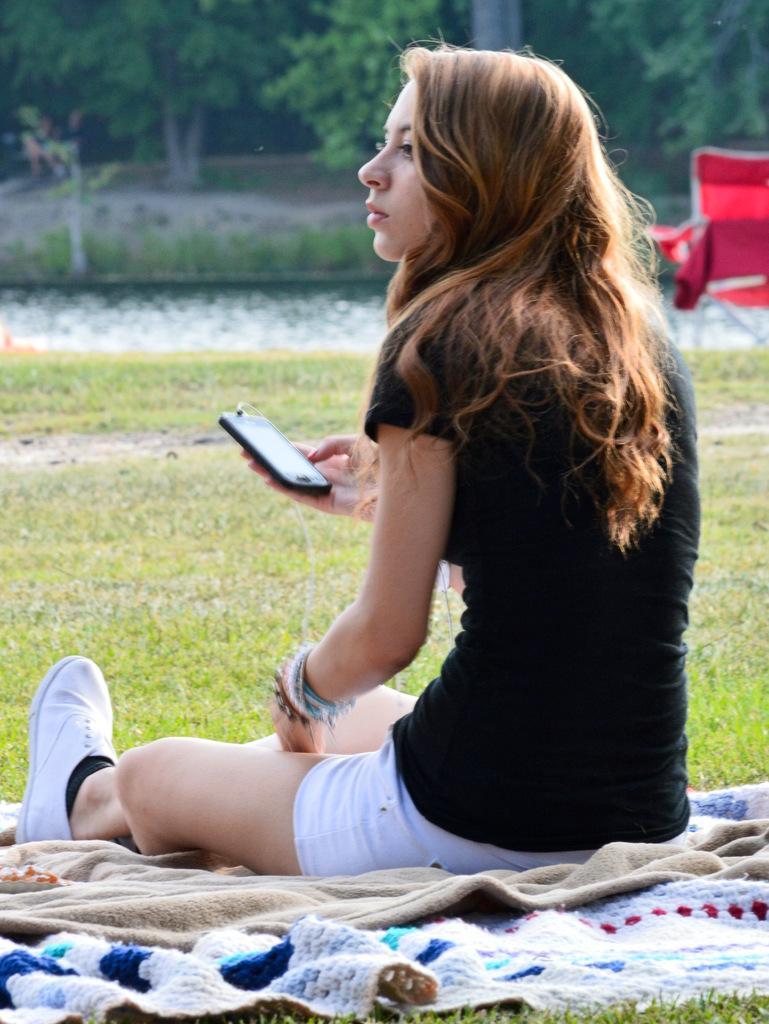In one or two sentences, can you explain what this image depicts? in this image the woman she is sitting on the bed sheet and she is holding the phone and she is wearing black t-shirt and white short and white shoes and the back ground is very morning. 